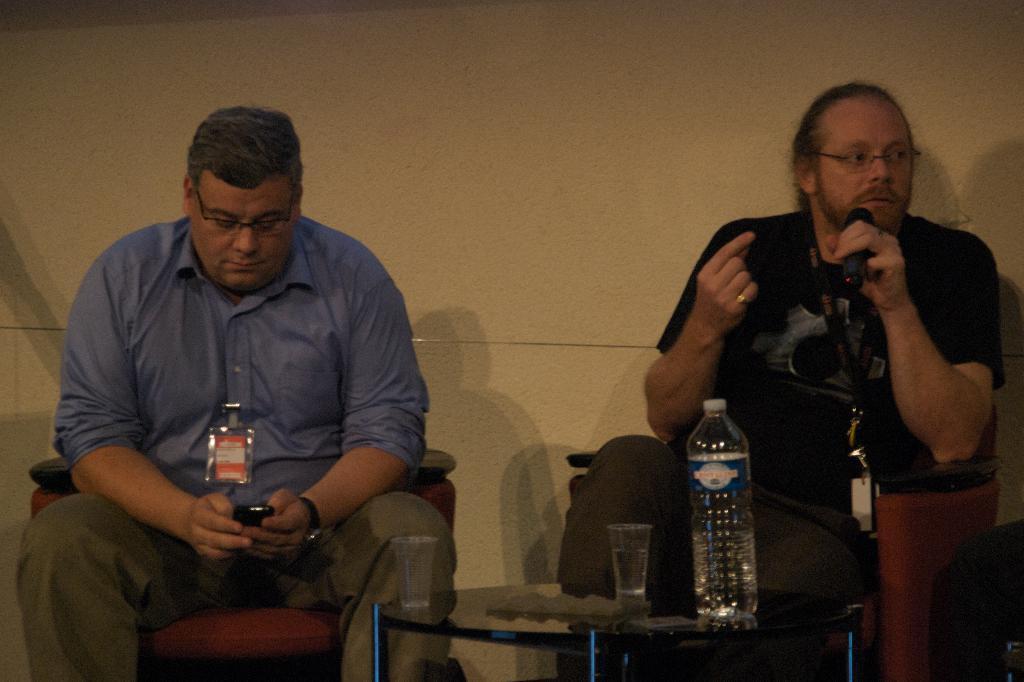Describe this image in one or two sentences. In this image I can see two people with different color dresses. These people are sitting on the chairs. I can see one person holding the mic and another person holding the mobile. There is a table in-front of these people. On the table I can see two glasses and the bottle. And there is a cream color wall in the back. 